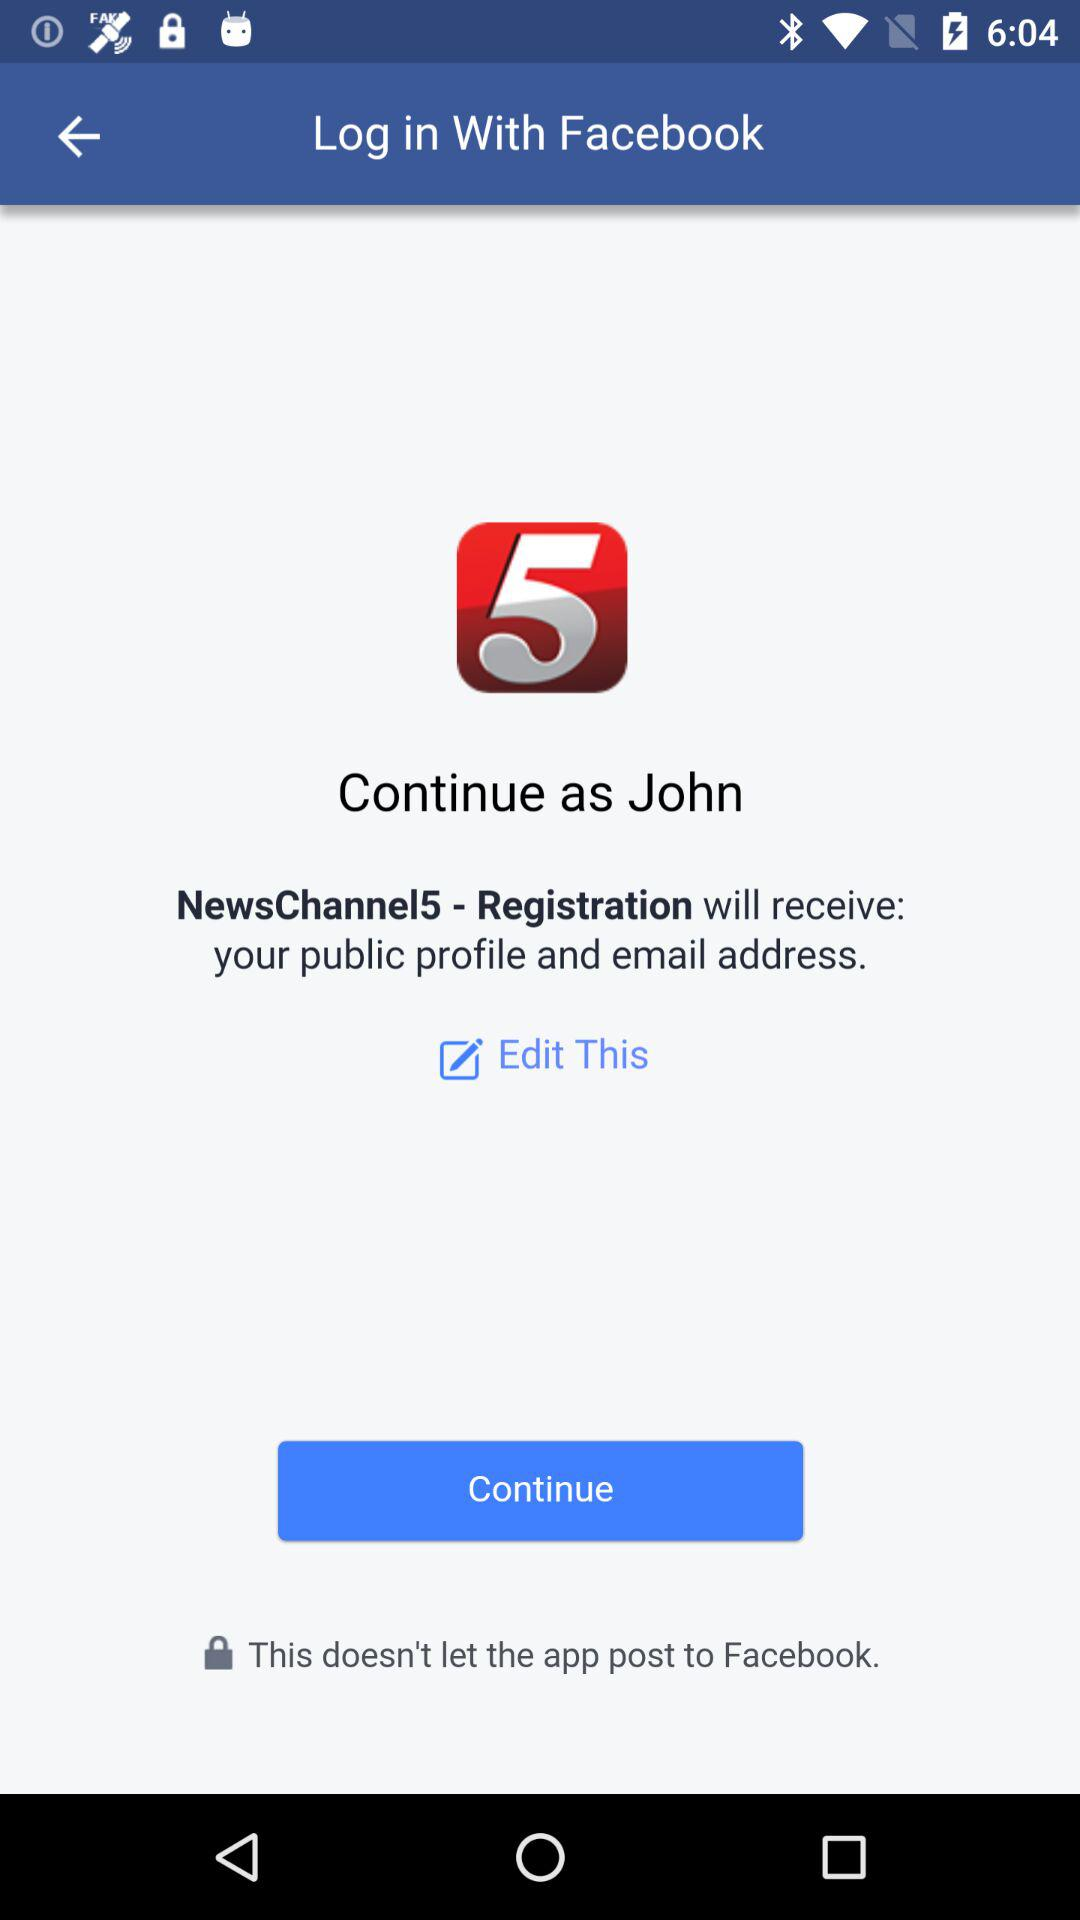What application is asking for permission? The application asking for permission is "NewsChannel5 - Registration". 